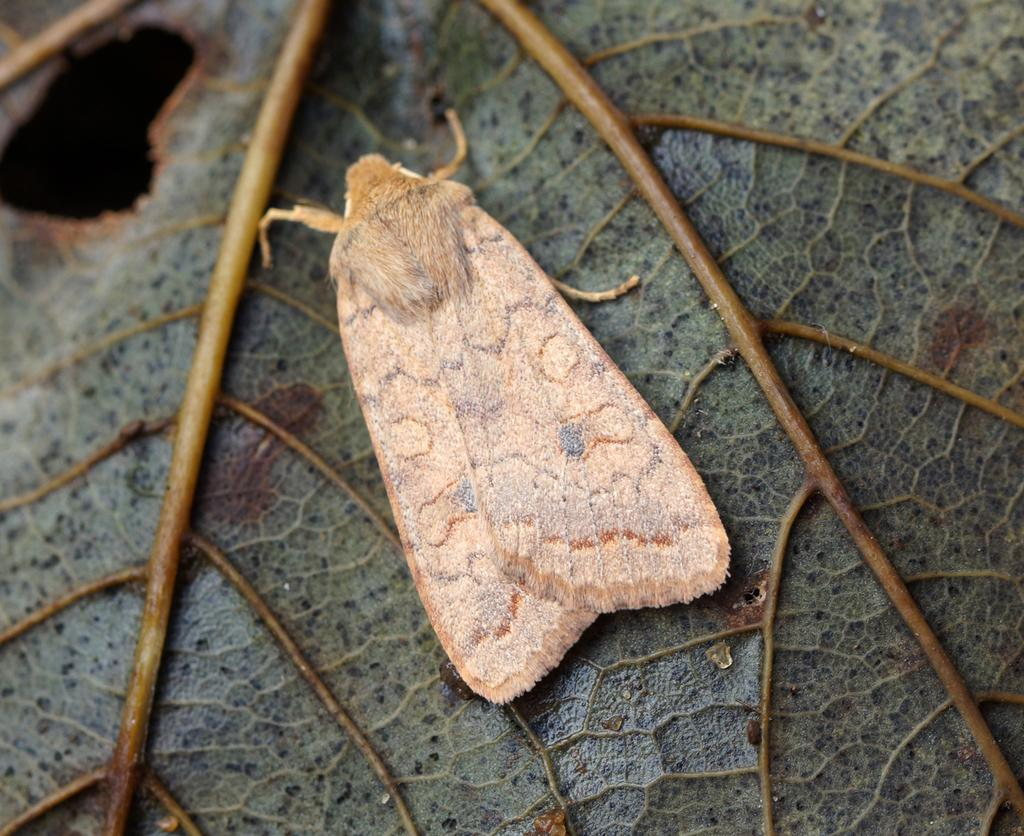What type of creature can be seen in the image? There is an insect in the image. Where is the insect located? The insect is on a leaf. What type of key is the insect using to unlock the door in the image? There is no key or door present in the image; it only features an insect on a leaf. 